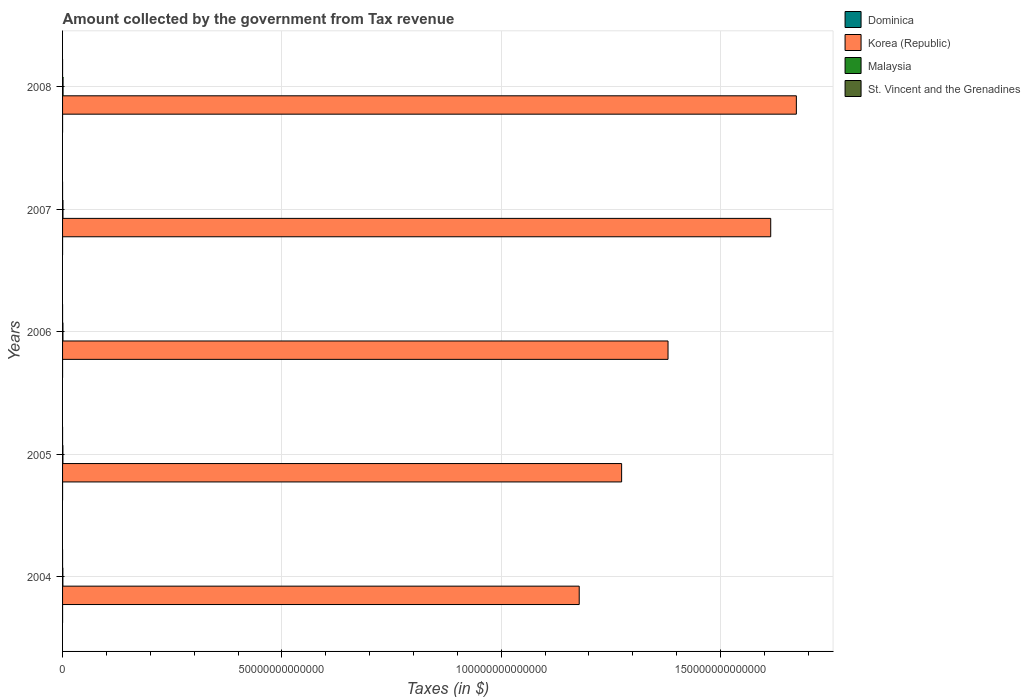How many different coloured bars are there?
Your answer should be compact. 4. Are the number of bars per tick equal to the number of legend labels?
Your answer should be compact. Yes. How many bars are there on the 1st tick from the top?
Keep it short and to the point. 4. How many bars are there on the 1st tick from the bottom?
Offer a very short reply. 4. What is the label of the 1st group of bars from the top?
Keep it short and to the point. 2008. In how many cases, is the number of bars for a given year not equal to the number of legend labels?
Offer a very short reply. 0. What is the amount collected by the government from tax revenue in Malaysia in 2005?
Your answer should be compact. 8.06e+1. Across all years, what is the maximum amount collected by the government from tax revenue in Malaysia?
Provide a succinct answer. 1.13e+11. Across all years, what is the minimum amount collected by the government from tax revenue in St. Vincent and the Grenadines?
Offer a very short reply. 2.91e+08. In which year was the amount collected by the government from tax revenue in Malaysia maximum?
Provide a short and direct response. 2008. What is the total amount collected by the government from tax revenue in Malaysia in the graph?
Make the answer very short. 4.47e+11. What is the difference between the amount collected by the government from tax revenue in Korea (Republic) in 2004 and that in 2005?
Your answer should be compact. -9.67e+12. What is the difference between the amount collected by the government from tax revenue in Malaysia in 2006 and the amount collected by the government from tax revenue in Korea (Republic) in 2008?
Your answer should be compact. -1.67e+14. What is the average amount collected by the government from tax revenue in Korea (Republic) per year?
Your response must be concise. 1.42e+14. In the year 2006, what is the difference between the amount collected by the government from tax revenue in Dominica and amount collected by the government from tax revenue in St. Vincent and the Grenadines?
Your answer should be compact. -1.15e+08. What is the ratio of the amount collected by the government from tax revenue in Korea (Republic) in 2005 to that in 2008?
Ensure brevity in your answer.  0.76. Is the difference between the amount collected by the government from tax revenue in Dominica in 2004 and 2005 greater than the difference between the amount collected by the government from tax revenue in St. Vincent and the Grenadines in 2004 and 2005?
Keep it short and to the point. No. What is the difference between the highest and the second highest amount collected by the government from tax revenue in St. Vincent and the Grenadines?
Your answer should be compact. 4.54e+07. What is the difference between the highest and the lowest amount collected by the government from tax revenue in Malaysia?
Give a very brief answer. 4.08e+1. In how many years, is the amount collected by the government from tax revenue in Korea (Republic) greater than the average amount collected by the government from tax revenue in Korea (Republic) taken over all years?
Provide a short and direct response. 2. Is it the case that in every year, the sum of the amount collected by the government from tax revenue in Malaysia and amount collected by the government from tax revenue in St. Vincent and the Grenadines is greater than the sum of amount collected by the government from tax revenue in Korea (Republic) and amount collected by the government from tax revenue in Dominica?
Ensure brevity in your answer.  Yes. What does the 2nd bar from the top in 2006 represents?
Ensure brevity in your answer.  Malaysia. What does the 4th bar from the bottom in 2004 represents?
Ensure brevity in your answer.  St. Vincent and the Grenadines. Are all the bars in the graph horizontal?
Provide a short and direct response. Yes. What is the difference between two consecutive major ticks on the X-axis?
Provide a succinct answer. 5.00e+13. Are the values on the major ticks of X-axis written in scientific E-notation?
Offer a terse response. No. How are the legend labels stacked?
Keep it short and to the point. Vertical. What is the title of the graph?
Your answer should be compact. Amount collected by the government from Tax revenue. What is the label or title of the X-axis?
Provide a short and direct response. Taxes (in $). What is the label or title of the Y-axis?
Your answer should be compact. Years. What is the Taxes (in $) in Dominica in 2004?
Provide a succinct answer. 2.05e+08. What is the Taxes (in $) in Korea (Republic) in 2004?
Ensure brevity in your answer.  1.18e+14. What is the Taxes (in $) in Malaysia in 2004?
Give a very brief answer. 7.21e+1. What is the Taxes (in $) in St. Vincent and the Grenadines in 2004?
Provide a succinct answer. 2.91e+08. What is the Taxes (in $) in Dominica in 2005?
Make the answer very short. 2.29e+08. What is the Taxes (in $) in Korea (Republic) in 2005?
Your response must be concise. 1.27e+14. What is the Taxes (in $) in Malaysia in 2005?
Your response must be concise. 8.06e+1. What is the Taxes (in $) of St. Vincent and the Grenadines in 2005?
Keep it short and to the point. 3.05e+08. What is the Taxes (in $) of Dominica in 2006?
Your answer should be compact. 2.48e+08. What is the Taxes (in $) of Korea (Republic) in 2006?
Keep it short and to the point. 1.38e+14. What is the Taxes (in $) in Malaysia in 2006?
Give a very brief answer. 8.66e+1. What is the Taxes (in $) of St. Vincent and the Grenadines in 2006?
Your answer should be very brief. 3.63e+08. What is the Taxes (in $) of Dominica in 2007?
Make the answer very short. 2.86e+08. What is the Taxes (in $) in Korea (Republic) in 2007?
Your answer should be compact. 1.61e+14. What is the Taxes (in $) of Malaysia in 2007?
Provide a short and direct response. 9.52e+1. What is the Taxes (in $) in St. Vincent and the Grenadines in 2007?
Keep it short and to the point. 4.03e+08. What is the Taxes (in $) of Dominica in 2008?
Your answer should be very brief. 3.07e+08. What is the Taxes (in $) of Korea (Republic) in 2008?
Offer a very short reply. 1.67e+14. What is the Taxes (in $) in Malaysia in 2008?
Your response must be concise. 1.13e+11. What is the Taxes (in $) of St. Vincent and the Grenadines in 2008?
Your response must be concise. 4.48e+08. Across all years, what is the maximum Taxes (in $) in Dominica?
Your response must be concise. 3.07e+08. Across all years, what is the maximum Taxes (in $) in Korea (Republic)?
Ensure brevity in your answer.  1.67e+14. Across all years, what is the maximum Taxes (in $) in Malaysia?
Ensure brevity in your answer.  1.13e+11. Across all years, what is the maximum Taxes (in $) in St. Vincent and the Grenadines?
Give a very brief answer. 4.48e+08. Across all years, what is the minimum Taxes (in $) of Dominica?
Offer a very short reply. 2.05e+08. Across all years, what is the minimum Taxes (in $) in Korea (Republic)?
Your response must be concise. 1.18e+14. Across all years, what is the minimum Taxes (in $) in Malaysia?
Provide a short and direct response. 7.21e+1. Across all years, what is the minimum Taxes (in $) of St. Vincent and the Grenadines?
Offer a terse response. 2.91e+08. What is the total Taxes (in $) of Dominica in the graph?
Provide a short and direct response. 1.28e+09. What is the total Taxes (in $) of Korea (Republic) in the graph?
Provide a succinct answer. 7.12e+14. What is the total Taxes (in $) in Malaysia in the graph?
Offer a very short reply. 4.47e+11. What is the total Taxes (in $) of St. Vincent and the Grenadines in the graph?
Your answer should be compact. 1.81e+09. What is the difference between the Taxes (in $) of Dominica in 2004 and that in 2005?
Offer a terse response. -2.41e+07. What is the difference between the Taxes (in $) of Korea (Republic) in 2004 and that in 2005?
Keep it short and to the point. -9.67e+12. What is the difference between the Taxes (in $) in Malaysia in 2004 and that in 2005?
Offer a very short reply. -8.54e+09. What is the difference between the Taxes (in $) in St. Vincent and the Grenadines in 2004 and that in 2005?
Offer a terse response. -1.44e+07. What is the difference between the Taxes (in $) in Dominica in 2004 and that in 2006?
Ensure brevity in your answer.  -4.27e+07. What is the difference between the Taxes (in $) in Korea (Republic) in 2004 and that in 2006?
Offer a very short reply. -2.02e+13. What is the difference between the Taxes (in $) of Malaysia in 2004 and that in 2006?
Offer a very short reply. -1.46e+1. What is the difference between the Taxes (in $) in St. Vincent and the Grenadines in 2004 and that in 2006?
Offer a very short reply. -7.19e+07. What is the difference between the Taxes (in $) in Dominica in 2004 and that in 2007?
Offer a terse response. -8.03e+07. What is the difference between the Taxes (in $) in Korea (Republic) in 2004 and that in 2007?
Provide a succinct answer. -4.37e+13. What is the difference between the Taxes (in $) in Malaysia in 2004 and that in 2007?
Offer a very short reply. -2.31e+1. What is the difference between the Taxes (in $) in St. Vincent and the Grenadines in 2004 and that in 2007?
Offer a terse response. -1.12e+08. What is the difference between the Taxes (in $) of Dominica in 2004 and that in 2008?
Your answer should be compact. -1.02e+08. What is the difference between the Taxes (in $) of Korea (Republic) in 2004 and that in 2008?
Offer a very short reply. -4.95e+13. What is the difference between the Taxes (in $) of Malaysia in 2004 and that in 2008?
Give a very brief answer. -4.08e+1. What is the difference between the Taxes (in $) of St. Vincent and the Grenadines in 2004 and that in 2008?
Offer a very short reply. -1.57e+08. What is the difference between the Taxes (in $) of Dominica in 2005 and that in 2006?
Make the answer very short. -1.86e+07. What is the difference between the Taxes (in $) of Korea (Republic) in 2005 and that in 2006?
Offer a terse response. -1.06e+13. What is the difference between the Taxes (in $) in Malaysia in 2005 and that in 2006?
Your response must be concise. -6.04e+09. What is the difference between the Taxes (in $) in St. Vincent and the Grenadines in 2005 and that in 2006?
Offer a very short reply. -5.75e+07. What is the difference between the Taxes (in $) of Dominica in 2005 and that in 2007?
Provide a short and direct response. -5.62e+07. What is the difference between the Taxes (in $) in Korea (Republic) in 2005 and that in 2007?
Offer a terse response. -3.40e+13. What is the difference between the Taxes (in $) in Malaysia in 2005 and that in 2007?
Give a very brief answer. -1.46e+1. What is the difference between the Taxes (in $) in St. Vincent and the Grenadines in 2005 and that in 2007?
Your answer should be very brief. -9.73e+07. What is the difference between the Taxes (in $) in Dominica in 2005 and that in 2008?
Ensure brevity in your answer.  -7.81e+07. What is the difference between the Taxes (in $) in Korea (Republic) in 2005 and that in 2008?
Your response must be concise. -3.98e+13. What is the difference between the Taxes (in $) in Malaysia in 2005 and that in 2008?
Ensure brevity in your answer.  -3.23e+1. What is the difference between the Taxes (in $) in St. Vincent and the Grenadines in 2005 and that in 2008?
Provide a short and direct response. -1.43e+08. What is the difference between the Taxes (in $) in Dominica in 2006 and that in 2007?
Make the answer very short. -3.76e+07. What is the difference between the Taxes (in $) in Korea (Republic) in 2006 and that in 2007?
Offer a terse response. -2.34e+13. What is the difference between the Taxes (in $) in Malaysia in 2006 and that in 2007?
Your answer should be compact. -8.54e+09. What is the difference between the Taxes (in $) in St. Vincent and the Grenadines in 2006 and that in 2007?
Keep it short and to the point. -3.98e+07. What is the difference between the Taxes (in $) of Dominica in 2006 and that in 2008?
Your answer should be compact. -5.95e+07. What is the difference between the Taxes (in $) in Korea (Republic) in 2006 and that in 2008?
Ensure brevity in your answer.  -2.93e+13. What is the difference between the Taxes (in $) of Malaysia in 2006 and that in 2008?
Offer a terse response. -2.63e+1. What is the difference between the Taxes (in $) in St. Vincent and the Grenadines in 2006 and that in 2008?
Give a very brief answer. -8.52e+07. What is the difference between the Taxes (in $) in Dominica in 2007 and that in 2008?
Provide a short and direct response. -2.19e+07. What is the difference between the Taxes (in $) in Korea (Republic) in 2007 and that in 2008?
Keep it short and to the point. -5.85e+12. What is the difference between the Taxes (in $) of Malaysia in 2007 and that in 2008?
Give a very brief answer. -1.77e+1. What is the difference between the Taxes (in $) in St. Vincent and the Grenadines in 2007 and that in 2008?
Keep it short and to the point. -4.54e+07. What is the difference between the Taxes (in $) in Dominica in 2004 and the Taxes (in $) in Korea (Republic) in 2005?
Your answer should be compact. -1.27e+14. What is the difference between the Taxes (in $) in Dominica in 2004 and the Taxes (in $) in Malaysia in 2005?
Offer a very short reply. -8.04e+1. What is the difference between the Taxes (in $) of Dominica in 2004 and the Taxes (in $) of St. Vincent and the Grenadines in 2005?
Your answer should be compact. -1.00e+08. What is the difference between the Taxes (in $) of Korea (Republic) in 2004 and the Taxes (in $) of Malaysia in 2005?
Ensure brevity in your answer.  1.18e+14. What is the difference between the Taxes (in $) in Korea (Republic) in 2004 and the Taxes (in $) in St. Vincent and the Grenadines in 2005?
Your response must be concise. 1.18e+14. What is the difference between the Taxes (in $) of Malaysia in 2004 and the Taxes (in $) of St. Vincent and the Grenadines in 2005?
Make the answer very short. 7.17e+1. What is the difference between the Taxes (in $) in Dominica in 2004 and the Taxes (in $) in Korea (Republic) in 2006?
Give a very brief answer. -1.38e+14. What is the difference between the Taxes (in $) of Dominica in 2004 and the Taxes (in $) of Malaysia in 2006?
Provide a succinct answer. -8.64e+1. What is the difference between the Taxes (in $) of Dominica in 2004 and the Taxes (in $) of St. Vincent and the Grenadines in 2006?
Provide a succinct answer. -1.58e+08. What is the difference between the Taxes (in $) of Korea (Republic) in 2004 and the Taxes (in $) of Malaysia in 2006?
Provide a succinct answer. 1.18e+14. What is the difference between the Taxes (in $) of Korea (Republic) in 2004 and the Taxes (in $) of St. Vincent and the Grenadines in 2006?
Keep it short and to the point. 1.18e+14. What is the difference between the Taxes (in $) in Malaysia in 2004 and the Taxes (in $) in St. Vincent and the Grenadines in 2006?
Your answer should be very brief. 7.17e+1. What is the difference between the Taxes (in $) of Dominica in 2004 and the Taxes (in $) of Korea (Republic) in 2007?
Keep it short and to the point. -1.61e+14. What is the difference between the Taxes (in $) of Dominica in 2004 and the Taxes (in $) of Malaysia in 2007?
Ensure brevity in your answer.  -9.50e+1. What is the difference between the Taxes (in $) in Dominica in 2004 and the Taxes (in $) in St. Vincent and the Grenadines in 2007?
Provide a short and direct response. -1.97e+08. What is the difference between the Taxes (in $) in Korea (Republic) in 2004 and the Taxes (in $) in Malaysia in 2007?
Your answer should be compact. 1.18e+14. What is the difference between the Taxes (in $) in Korea (Republic) in 2004 and the Taxes (in $) in St. Vincent and the Grenadines in 2007?
Provide a succinct answer. 1.18e+14. What is the difference between the Taxes (in $) in Malaysia in 2004 and the Taxes (in $) in St. Vincent and the Grenadines in 2007?
Offer a terse response. 7.16e+1. What is the difference between the Taxes (in $) in Dominica in 2004 and the Taxes (in $) in Korea (Republic) in 2008?
Your answer should be very brief. -1.67e+14. What is the difference between the Taxes (in $) in Dominica in 2004 and the Taxes (in $) in Malaysia in 2008?
Your response must be concise. -1.13e+11. What is the difference between the Taxes (in $) in Dominica in 2004 and the Taxes (in $) in St. Vincent and the Grenadines in 2008?
Your response must be concise. -2.43e+08. What is the difference between the Taxes (in $) in Korea (Republic) in 2004 and the Taxes (in $) in Malaysia in 2008?
Your answer should be compact. 1.18e+14. What is the difference between the Taxes (in $) of Korea (Republic) in 2004 and the Taxes (in $) of St. Vincent and the Grenadines in 2008?
Ensure brevity in your answer.  1.18e+14. What is the difference between the Taxes (in $) of Malaysia in 2004 and the Taxes (in $) of St. Vincent and the Grenadines in 2008?
Make the answer very short. 7.16e+1. What is the difference between the Taxes (in $) in Dominica in 2005 and the Taxes (in $) in Korea (Republic) in 2006?
Your answer should be very brief. -1.38e+14. What is the difference between the Taxes (in $) in Dominica in 2005 and the Taxes (in $) in Malaysia in 2006?
Your response must be concise. -8.64e+1. What is the difference between the Taxes (in $) of Dominica in 2005 and the Taxes (in $) of St. Vincent and the Grenadines in 2006?
Offer a terse response. -1.34e+08. What is the difference between the Taxes (in $) in Korea (Republic) in 2005 and the Taxes (in $) in Malaysia in 2006?
Your answer should be compact. 1.27e+14. What is the difference between the Taxes (in $) in Korea (Republic) in 2005 and the Taxes (in $) in St. Vincent and the Grenadines in 2006?
Your answer should be compact. 1.27e+14. What is the difference between the Taxes (in $) in Malaysia in 2005 and the Taxes (in $) in St. Vincent and the Grenadines in 2006?
Give a very brief answer. 8.02e+1. What is the difference between the Taxes (in $) of Dominica in 2005 and the Taxes (in $) of Korea (Republic) in 2007?
Your answer should be compact. -1.61e+14. What is the difference between the Taxes (in $) in Dominica in 2005 and the Taxes (in $) in Malaysia in 2007?
Provide a short and direct response. -9.49e+1. What is the difference between the Taxes (in $) in Dominica in 2005 and the Taxes (in $) in St. Vincent and the Grenadines in 2007?
Your response must be concise. -1.73e+08. What is the difference between the Taxes (in $) of Korea (Republic) in 2005 and the Taxes (in $) of Malaysia in 2007?
Provide a short and direct response. 1.27e+14. What is the difference between the Taxes (in $) in Korea (Republic) in 2005 and the Taxes (in $) in St. Vincent and the Grenadines in 2007?
Give a very brief answer. 1.27e+14. What is the difference between the Taxes (in $) of Malaysia in 2005 and the Taxes (in $) of St. Vincent and the Grenadines in 2007?
Give a very brief answer. 8.02e+1. What is the difference between the Taxes (in $) in Dominica in 2005 and the Taxes (in $) in Korea (Republic) in 2008?
Your response must be concise. -1.67e+14. What is the difference between the Taxes (in $) in Dominica in 2005 and the Taxes (in $) in Malaysia in 2008?
Ensure brevity in your answer.  -1.13e+11. What is the difference between the Taxes (in $) of Dominica in 2005 and the Taxes (in $) of St. Vincent and the Grenadines in 2008?
Offer a very short reply. -2.19e+08. What is the difference between the Taxes (in $) of Korea (Republic) in 2005 and the Taxes (in $) of Malaysia in 2008?
Offer a very short reply. 1.27e+14. What is the difference between the Taxes (in $) of Korea (Republic) in 2005 and the Taxes (in $) of St. Vincent and the Grenadines in 2008?
Provide a short and direct response. 1.27e+14. What is the difference between the Taxes (in $) in Malaysia in 2005 and the Taxes (in $) in St. Vincent and the Grenadines in 2008?
Keep it short and to the point. 8.01e+1. What is the difference between the Taxes (in $) of Dominica in 2006 and the Taxes (in $) of Korea (Republic) in 2007?
Give a very brief answer. -1.61e+14. What is the difference between the Taxes (in $) of Dominica in 2006 and the Taxes (in $) of Malaysia in 2007?
Provide a short and direct response. -9.49e+1. What is the difference between the Taxes (in $) in Dominica in 2006 and the Taxes (in $) in St. Vincent and the Grenadines in 2007?
Offer a terse response. -1.55e+08. What is the difference between the Taxes (in $) in Korea (Republic) in 2006 and the Taxes (in $) in Malaysia in 2007?
Ensure brevity in your answer.  1.38e+14. What is the difference between the Taxes (in $) in Korea (Republic) in 2006 and the Taxes (in $) in St. Vincent and the Grenadines in 2007?
Give a very brief answer. 1.38e+14. What is the difference between the Taxes (in $) of Malaysia in 2006 and the Taxes (in $) of St. Vincent and the Grenadines in 2007?
Your answer should be compact. 8.62e+1. What is the difference between the Taxes (in $) in Dominica in 2006 and the Taxes (in $) in Korea (Republic) in 2008?
Your answer should be compact. -1.67e+14. What is the difference between the Taxes (in $) of Dominica in 2006 and the Taxes (in $) of Malaysia in 2008?
Give a very brief answer. -1.13e+11. What is the difference between the Taxes (in $) in Dominica in 2006 and the Taxes (in $) in St. Vincent and the Grenadines in 2008?
Your answer should be very brief. -2.00e+08. What is the difference between the Taxes (in $) in Korea (Republic) in 2006 and the Taxes (in $) in Malaysia in 2008?
Make the answer very short. 1.38e+14. What is the difference between the Taxes (in $) of Korea (Republic) in 2006 and the Taxes (in $) of St. Vincent and the Grenadines in 2008?
Your answer should be compact. 1.38e+14. What is the difference between the Taxes (in $) of Malaysia in 2006 and the Taxes (in $) of St. Vincent and the Grenadines in 2008?
Your answer should be very brief. 8.62e+1. What is the difference between the Taxes (in $) of Dominica in 2007 and the Taxes (in $) of Korea (Republic) in 2008?
Your response must be concise. -1.67e+14. What is the difference between the Taxes (in $) of Dominica in 2007 and the Taxes (in $) of Malaysia in 2008?
Keep it short and to the point. -1.13e+11. What is the difference between the Taxes (in $) of Dominica in 2007 and the Taxes (in $) of St. Vincent and the Grenadines in 2008?
Provide a succinct answer. -1.62e+08. What is the difference between the Taxes (in $) of Korea (Republic) in 2007 and the Taxes (in $) of Malaysia in 2008?
Offer a very short reply. 1.61e+14. What is the difference between the Taxes (in $) of Korea (Republic) in 2007 and the Taxes (in $) of St. Vincent and the Grenadines in 2008?
Offer a terse response. 1.61e+14. What is the difference between the Taxes (in $) in Malaysia in 2007 and the Taxes (in $) in St. Vincent and the Grenadines in 2008?
Provide a succinct answer. 9.47e+1. What is the average Taxes (in $) of Dominica per year?
Make the answer very short. 2.55e+08. What is the average Taxes (in $) of Korea (Republic) per year?
Make the answer very short. 1.42e+14. What is the average Taxes (in $) in Malaysia per year?
Your answer should be very brief. 8.95e+1. What is the average Taxes (in $) of St. Vincent and the Grenadines per year?
Your response must be concise. 3.62e+08. In the year 2004, what is the difference between the Taxes (in $) in Dominica and Taxes (in $) in Korea (Republic)?
Ensure brevity in your answer.  -1.18e+14. In the year 2004, what is the difference between the Taxes (in $) in Dominica and Taxes (in $) in Malaysia?
Provide a succinct answer. -7.18e+1. In the year 2004, what is the difference between the Taxes (in $) of Dominica and Taxes (in $) of St. Vincent and the Grenadines?
Ensure brevity in your answer.  -8.57e+07. In the year 2004, what is the difference between the Taxes (in $) of Korea (Republic) and Taxes (in $) of Malaysia?
Offer a terse response. 1.18e+14. In the year 2004, what is the difference between the Taxes (in $) in Korea (Republic) and Taxes (in $) in St. Vincent and the Grenadines?
Give a very brief answer. 1.18e+14. In the year 2004, what is the difference between the Taxes (in $) of Malaysia and Taxes (in $) of St. Vincent and the Grenadines?
Offer a terse response. 7.18e+1. In the year 2005, what is the difference between the Taxes (in $) in Dominica and Taxes (in $) in Korea (Republic)?
Keep it short and to the point. -1.27e+14. In the year 2005, what is the difference between the Taxes (in $) in Dominica and Taxes (in $) in Malaysia?
Your answer should be compact. -8.04e+1. In the year 2005, what is the difference between the Taxes (in $) of Dominica and Taxes (in $) of St. Vincent and the Grenadines?
Your answer should be very brief. -7.60e+07. In the year 2005, what is the difference between the Taxes (in $) in Korea (Republic) and Taxes (in $) in Malaysia?
Your answer should be compact. 1.27e+14. In the year 2005, what is the difference between the Taxes (in $) of Korea (Republic) and Taxes (in $) of St. Vincent and the Grenadines?
Keep it short and to the point. 1.27e+14. In the year 2005, what is the difference between the Taxes (in $) of Malaysia and Taxes (in $) of St. Vincent and the Grenadines?
Your answer should be compact. 8.03e+1. In the year 2006, what is the difference between the Taxes (in $) of Dominica and Taxes (in $) of Korea (Republic)?
Provide a succinct answer. -1.38e+14. In the year 2006, what is the difference between the Taxes (in $) of Dominica and Taxes (in $) of Malaysia?
Offer a terse response. -8.64e+1. In the year 2006, what is the difference between the Taxes (in $) of Dominica and Taxes (in $) of St. Vincent and the Grenadines?
Provide a succinct answer. -1.15e+08. In the year 2006, what is the difference between the Taxes (in $) in Korea (Republic) and Taxes (in $) in Malaysia?
Your answer should be very brief. 1.38e+14. In the year 2006, what is the difference between the Taxes (in $) of Korea (Republic) and Taxes (in $) of St. Vincent and the Grenadines?
Provide a short and direct response. 1.38e+14. In the year 2006, what is the difference between the Taxes (in $) in Malaysia and Taxes (in $) in St. Vincent and the Grenadines?
Give a very brief answer. 8.63e+1. In the year 2007, what is the difference between the Taxes (in $) of Dominica and Taxes (in $) of Korea (Republic)?
Your answer should be compact. -1.61e+14. In the year 2007, what is the difference between the Taxes (in $) in Dominica and Taxes (in $) in Malaysia?
Your response must be concise. -9.49e+1. In the year 2007, what is the difference between the Taxes (in $) in Dominica and Taxes (in $) in St. Vincent and the Grenadines?
Your answer should be compact. -1.17e+08. In the year 2007, what is the difference between the Taxes (in $) of Korea (Republic) and Taxes (in $) of Malaysia?
Provide a short and direct response. 1.61e+14. In the year 2007, what is the difference between the Taxes (in $) of Korea (Republic) and Taxes (in $) of St. Vincent and the Grenadines?
Make the answer very short. 1.61e+14. In the year 2007, what is the difference between the Taxes (in $) of Malaysia and Taxes (in $) of St. Vincent and the Grenadines?
Give a very brief answer. 9.48e+1. In the year 2008, what is the difference between the Taxes (in $) in Dominica and Taxes (in $) in Korea (Republic)?
Keep it short and to the point. -1.67e+14. In the year 2008, what is the difference between the Taxes (in $) in Dominica and Taxes (in $) in Malaysia?
Give a very brief answer. -1.13e+11. In the year 2008, what is the difference between the Taxes (in $) of Dominica and Taxes (in $) of St. Vincent and the Grenadines?
Give a very brief answer. -1.41e+08. In the year 2008, what is the difference between the Taxes (in $) of Korea (Republic) and Taxes (in $) of Malaysia?
Your answer should be compact. 1.67e+14. In the year 2008, what is the difference between the Taxes (in $) in Korea (Republic) and Taxes (in $) in St. Vincent and the Grenadines?
Provide a short and direct response. 1.67e+14. In the year 2008, what is the difference between the Taxes (in $) of Malaysia and Taxes (in $) of St. Vincent and the Grenadines?
Your response must be concise. 1.12e+11. What is the ratio of the Taxes (in $) of Dominica in 2004 to that in 2005?
Offer a terse response. 0.89. What is the ratio of the Taxes (in $) in Korea (Republic) in 2004 to that in 2005?
Provide a succinct answer. 0.92. What is the ratio of the Taxes (in $) of Malaysia in 2004 to that in 2005?
Make the answer very short. 0.89. What is the ratio of the Taxes (in $) of St. Vincent and the Grenadines in 2004 to that in 2005?
Ensure brevity in your answer.  0.95. What is the ratio of the Taxes (in $) in Dominica in 2004 to that in 2006?
Your response must be concise. 0.83. What is the ratio of the Taxes (in $) in Korea (Republic) in 2004 to that in 2006?
Provide a short and direct response. 0.85. What is the ratio of the Taxes (in $) of Malaysia in 2004 to that in 2006?
Provide a succinct answer. 0.83. What is the ratio of the Taxes (in $) in St. Vincent and the Grenadines in 2004 to that in 2006?
Offer a very short reply. 0.8. What is the ratio of the Taxes (in $) in Dominica in 2004 to that in 2007?
Offer a very short reply. 0.72. What is the ratio of the Taxes (in $) in Korea (Republic) in 2004 to that in 2007?
Provide a short and direct response. 0.73. What is the ratio of the Taxes (in $) of Malaysia in 2004 to that in 2007?
Provide a short and direct response. 0.76. What is the ratio of the Taxes (in $) of St. Vincent and the Grenadines in 2004 to that in 2007?
Keep it short and to the point. 0.72. What is the ratio of the Taxes (in $) in Dominica in 2004 to that in 2008?
Your response must be concise. 0.67. What is the ratio of the Taxes (in $) in Korea (Republic) in 2004 to that in 2008?
Your answer should be very brief. 0.7. What is the ratio of the Taxes (in $) of Malaysia in 2004 to that in 2008?
Offer a terse response. 0.64. What is the ratio of the Taxes (in $) in St. Vincent and the Grenadines in 2004 to that in 2008?
Offer a terse response. 0.65. What is the ratio of the Taxes (in $) of Dominica in 2005 to that in 2006?
Offer a very short reply. 0.93. What is the ratio of the Taxes (in $) of Korea (Republic) in 2005 to that in 2006?
Your response must be concise. 0.92. What is the ratio of the Taxes (in $) in Malaysia in 2005 to that in 2006?
Provide a succinct answer. 0.93. What is the ratio of the Taxes (in $) in St. Vincent and the Grenadines in 2005 to that in 2006?
Give a very brief answer. 0.84. What is the ratio of the Taxes (in $) of Dominica in 2005 to that in 2007?
Provide a succinct answer. 0.8. What is the ratio of the Taxes (in $) in Korea (Republic) in 2005 to that in 2007?
Offer a very short reply. 0.79. What is the ratio of the Taxes (in $) of Malaysia in 2005 to that in 2007?
Give a very brief answer. 0.85. What is the ratio of the Taxes (in $) in St. Vincent and the Grenadines in 2005 to that in 2007?
Offer a terse response. 0.76. What is the ratio of the Taxes (in $) in Dominica in 2005 to that in 2008?
Your answer should be very brief. 0.75. What is the ratio of the Taxes (in $) of Korea (Republic) in 2005 to that in 2008?
Keep it short and to the point. 0.76. What is the ratio of the Taxes (in $) in Malaysia in 2005 to that in 2008?
Keep it short and to the point. 0.71. What is the ratio of the Taxes (in $) of St. Vincent and the Grenadines in 2005 to that in 2008?
Offer a very short reply. 0.68. What is the ratio of the Taxes (in $) of Dominica in 2006 to that in 2007?
Provide a short and direct response. 0.87. What is the ratio of the Taxes (in $) in Korea (Republic) in 2006 to that in 2007?
Your answer should be very brief. 0.85. What is the ratio of the Taxes (in $) of Malaysia in 2006 to that in 2007?
Provide a short and direct response. 0.91. What is the ratio of the Taxes (in $) in St. Vincent and the Grenadines in 2006 to that in 2007?
Your answer should be compact. 0.9. What is the ratio of the Taxes (in $) in Dominica in 2006 to that in 2008?
Offer a very short reply. 0.81. What is the ratio of the Taxes (in $) of Korea (Republic) in 2006 to that in 2008?
Keep it short and to the point. 0.83. What is the ratio of the Taxes (in $) of Malaysia in 2006 to that in 2008?
Give a very brief answer. 0.77. What is the ratio of the Taxes (in $) of St. Vincent and the Grenadines in 2006 to that in 2008?
Your response must be concise. 0.81. What is the ratio of the Taxes (in $) in Dominica in 2007 to that in 2008?
Provide a succinct answer. 0.93. What is the ratio of the Taxes (in $) of Korea (Republic) in 2007 to that in 2008?
Ensure brevity in your answer.  0.97. What is the ratio of the Taxes (in $) of Malaysia in 2007 to that in 2008?
Provide a succinct answer. 0.84. What is the ratio of the Taxes (in $) in St. Vincent and the Grenadines in 2007 to that in 2008?
Make the answer very short. 0.9. What is the difference between the highest and the second highest Taxes (in $) in Dominica?
Give a very brief answer. 2.19e+07. What is the difference between the highest and the second highest Taxes (in $) in Korea (Republic)?
Provide a succinct answer. 5.85e+12. What is the difference between the highest and the second highest Taxes (in $) of Malaysia?
Your response must be concise. 1.77e+1. What is the difference between the highest and the second highest Taxes (in $) of St. Vincent and the Grenadines?
Provide a short and direct response. 4.54e+07. What is the difference between the highest and the lowest Taxes (in $) in Dominica?
Offer a terse response. 1.02e+08. What is the difference between the highest and the lowest Taxes (in $) of Korea (Republic)?
Your answer should be compact. 4.95e+13. What is the difference between the highest and the lowest Taxes (in $) of Malaysia?
Your response must be concise. 4.08e+1. What is the difference between the highest and the lowest Taxes (in $) in St. Vincent and the Grenadines?
Make the answer very short. 1.57e+08. 